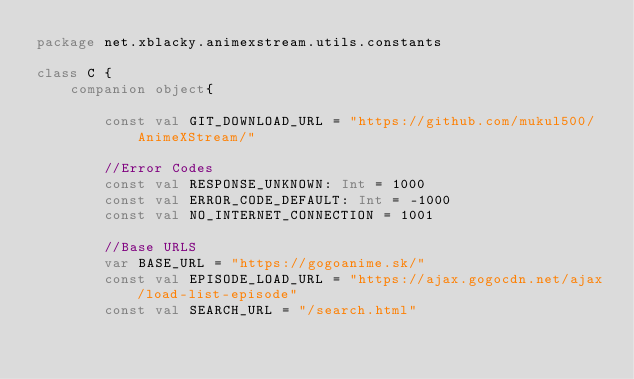<code> <loc_0><loc_0><loc_500><loc_500><_Kotlin_>package net.xblacky.animexstream.utils.constants

class C {
    companion object{

        const val GIT_DOWNLOAD_URL = "https://github.com/mukul500/AnimeXStream/"

        //Error Codes
        const val RESPONSE_UNKNOWN: Int = 1000
        const val ERROR_CODE_DEFAULT: Int = -1000
        const val NO_INTERNET_CONNECTION = 1001

        //Base URLS
        var BASE_URL = "https://gogoanime.sk/"
        const val EPISODE_LOAD_URL = "https://ajax.gogocdn.net/ajax/load-list-episode"
        const val SEARCH_URL = "/search.html"

</code> 